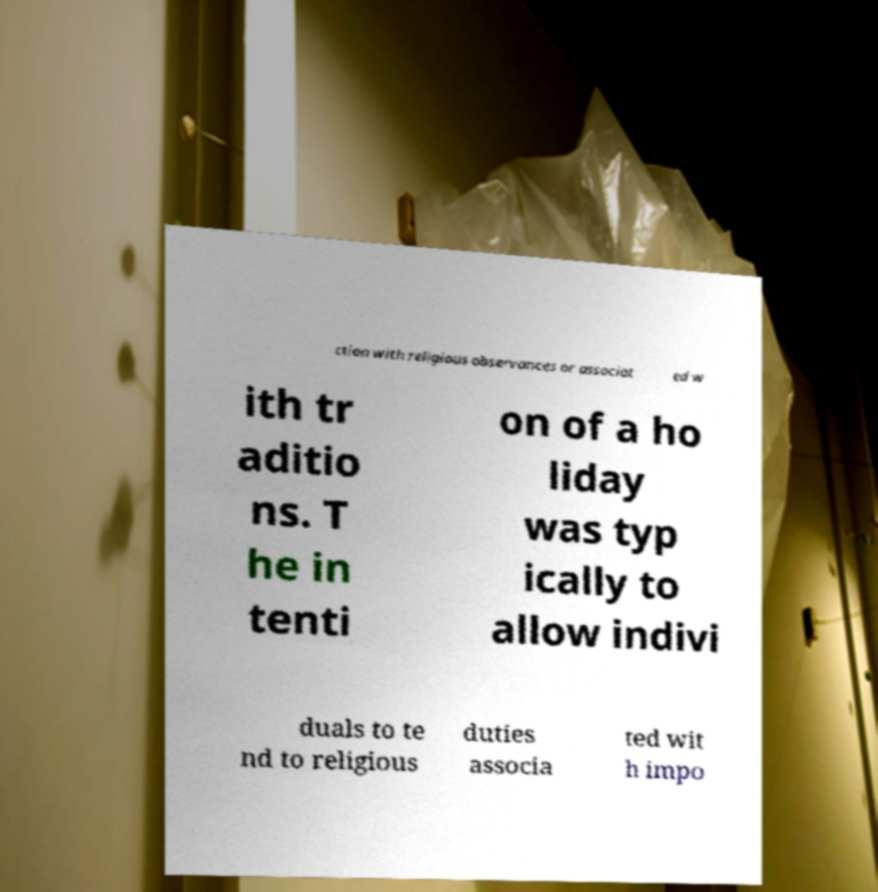Please read and relay the text visible in this image. What does it say? ction with religious observances or associat ed w ith tr aditio ns. T he in tenti on of a ho liday was typ ically to allow indivi duals to te nd to religious duties associa ted wit h impo 